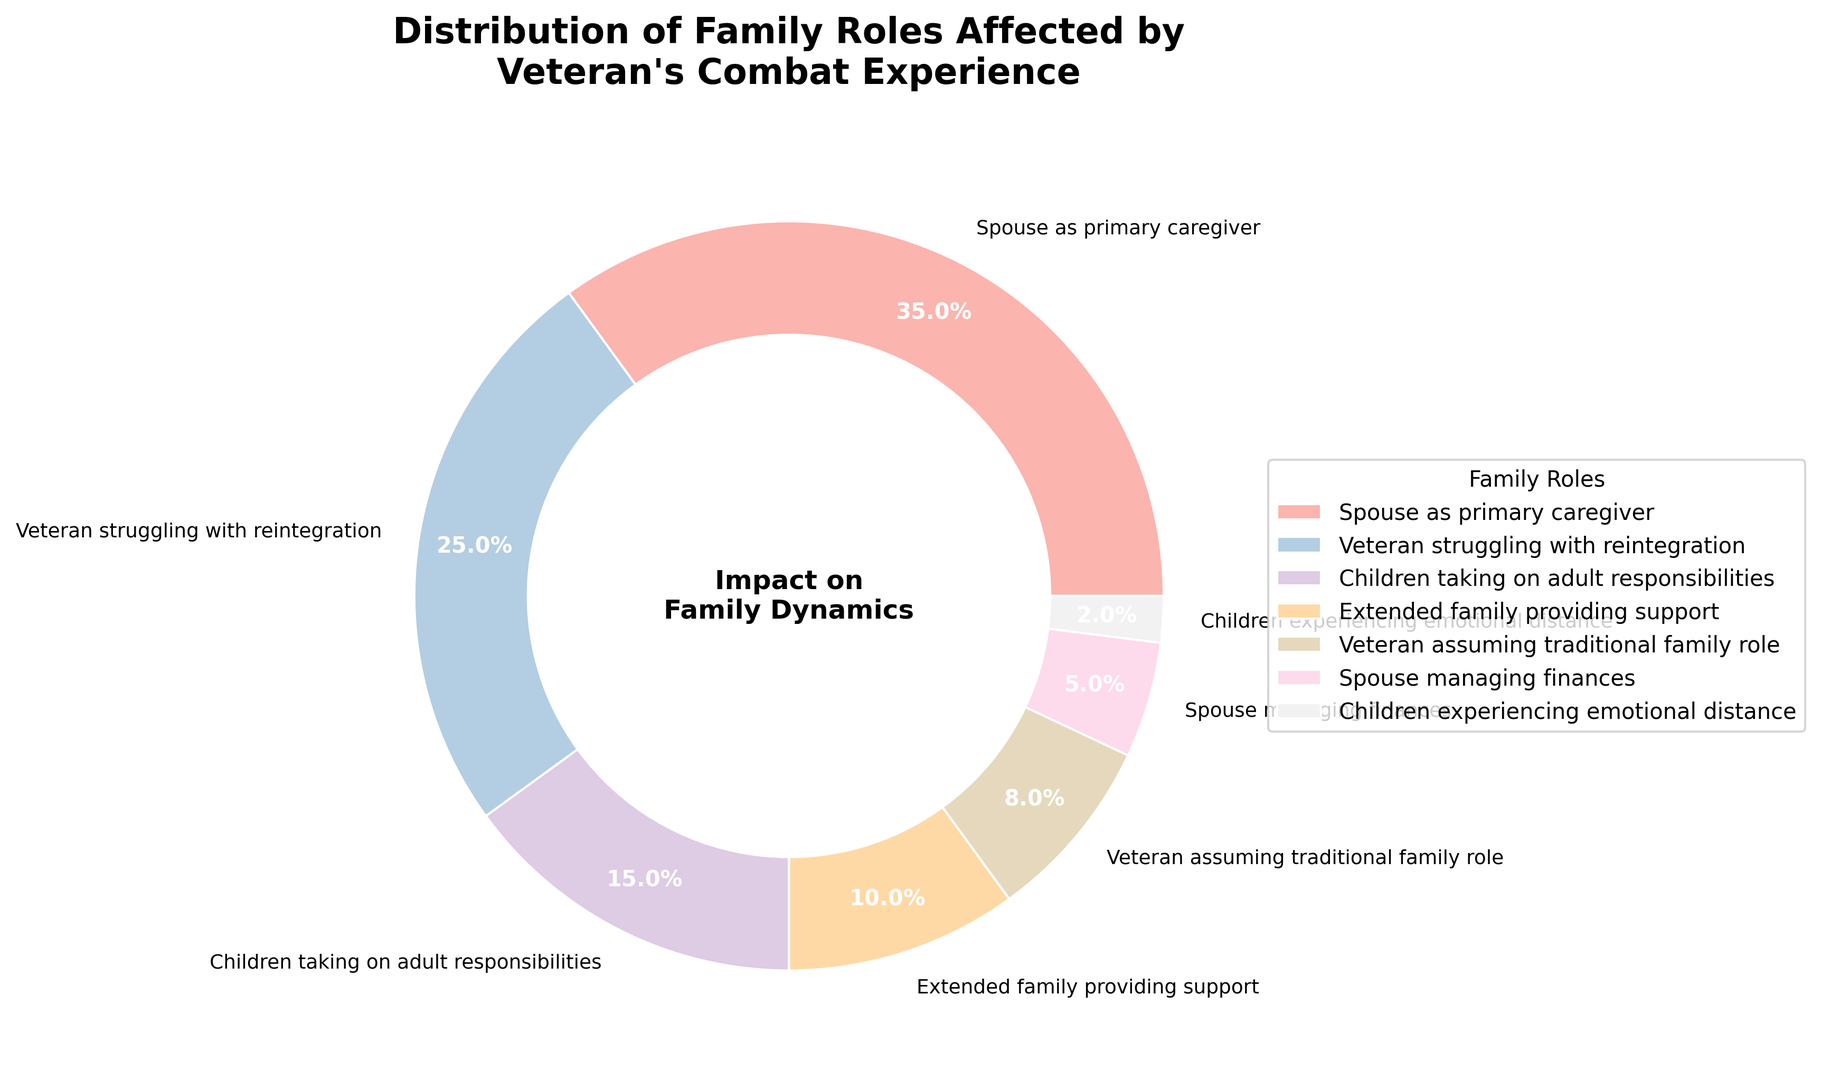Which family role is the most affected by a veteran's combat experience based on the figure? Look for the largest wedge in the pie chart. The label with the highest percentage represents the most affected role.
Answer: Spouse as primary caregiver What is the combined percentage of children taking on adult responsibilities and children experiencing emotional distance? Find the percentages for both roles in the figure (15% and 2%), then sum them together: 15% + 2% = 17%.
Answer: 17% Is the percentage of veterans struggling with reintegration higher than the percentage of extended family providing support? Compare the two wedges. "Veteran struggling with reintegration" is 25%, while "Extended family providing support" is 10%.
Answer: Yes Which family roles have percentages in single digits? Identify roles from the chart with percentages less than 10%. They are "Veteran assuming traditional family role" (8%) and "Spouse managing finances" (5%).
Answer: Veteran assuming traditional family role, Spouse managing finances How much larger is the percentage of spouses as primary caregivers compared to the percentage of veterans assuming traditional family roles? Subtract the percentage of "Veteran assuming traditional family roles" (8%) from "Spouse as primary caregiver" (35%): 35% - 8% = 27%.
Answer: 27% What is the average percentage of the three least affected family roles? Identify the three least affected roles: "Children experiencing emotional distance" (2%), "Spouse managing finances" (5%), and "Veteran assuming traditional family roles" (8%). Sum these values (2% + 5% + 8% = 15%) and divide by three: 15% / 3 = 5%.
Answer: 5% Which wedge in the pie chart is represented in a darker shade compared to "Extended family providing support"? Look for a wedge with a visibly darker shade than the color of "Extended family providing support". The role "Veteran struggling with reintegration" should appear in a darker shade based on color coding.
Answer: Veteran struggling with reintegration What is the total percentage of roles involving direct involvement of the veteran? Add the percentages of roles directly involving the veteran: "Veteran struggling with reintegration" (25%) and "Veteran assuming traditional family role" (8%): 25% + 8% = 33%.
Answer: 33% Does the wedge for "Spouse managing finances" occupy a larger or smaller space compared to "Children taking on adult responsibilities"? Compare the sizes of the slices. "Spouse managing finances" is 5%, while "Children taking on adult responsibilities" is 15%.
Answer: Smaller What is the combined impact percentage on the spouse (primary caregiver and managing finances)? Sum the percentages of both roles involving the spouse: "Spouse as primary caregiver" (35%) and "Spouse managing finances" (5%): 35% + 5% = 40%.
Answer: 40% 